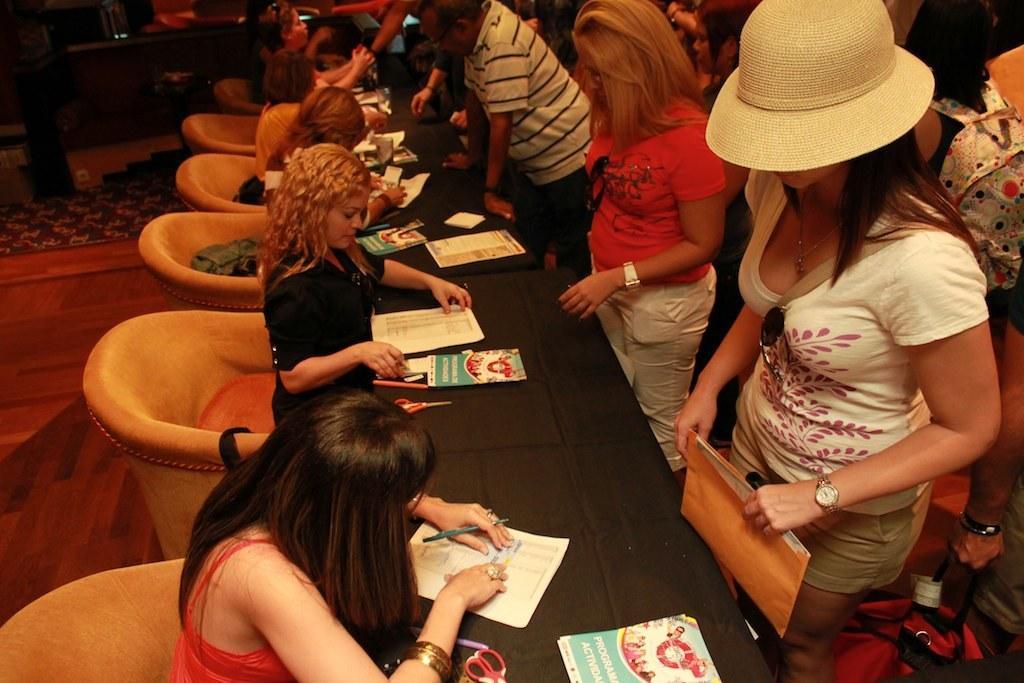Describe this image in one or two sentences. In the middle, there is a black color table , On that table there are some books and there are some people sitting on the chairs, And there are some peoples standing and in the background there is a brown color table. 